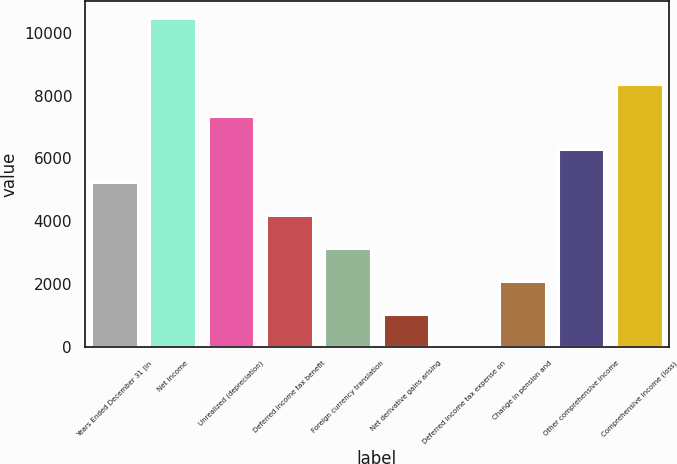Convert chart to OTSL. <chart><loc_0><loc_0><loc_500><loc_500><bar_chart><fcel>Years Ended December 31 (in<fcel>Net income<fcel>Unrealized (depreciation)<fcel>Deferred income tax benefit<fcel>Foreign currency translation<fcel>Net derivative gains arising<fcel>Deferred income tax expense on<fcel>Change in pension and<fcel>Other comprehensive income<fcel>Comprehensive income (loss)<nl><fcel>5242<fcel>10477<fcel>7336<fcel>4195<fcel>3148<fcel>1054<fcel>7<fcel>2101<fcel>6289<fcel>8383<nl></chart> 